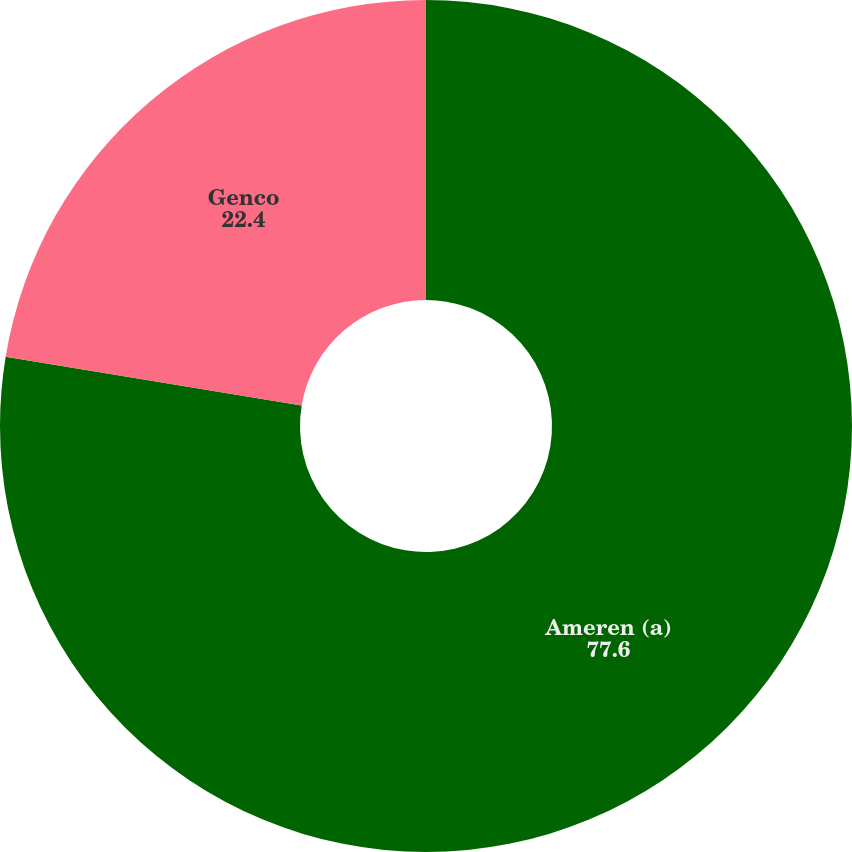Convert chart. <chart><loc_0><loc_0><loc_500><loc_500><pie_chart><fcel>Ameren (a)<fcel>Genco<nl><fcel>77.6%<fcel>22.4%<nl></chart> 